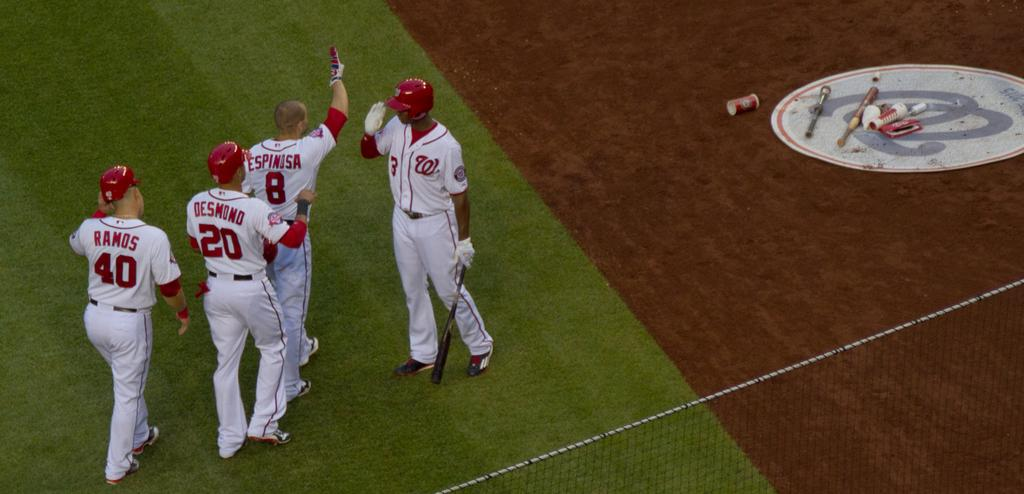<image>
Relay a brief, clear account of the picture shown. Ball players named Ramos, Desmond and Espinos on a field. 